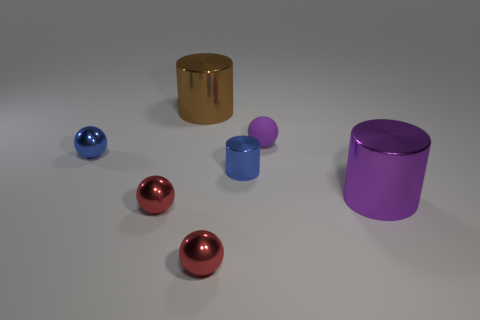Add 2 small cylinders. How many objects exist? 9 Subtract all cylinders. How many objects are left? 4 Subtract 2 red balls. How many objects are left? 5 Subtract all tiny blue cylinders. Subtract all purple matte objects. How many objects are left? 5 Add 7 purple shiny objects. How many purple shiny objects are left? 8 Add 1 green matte spheres. How many green matte spheres exist? 1 